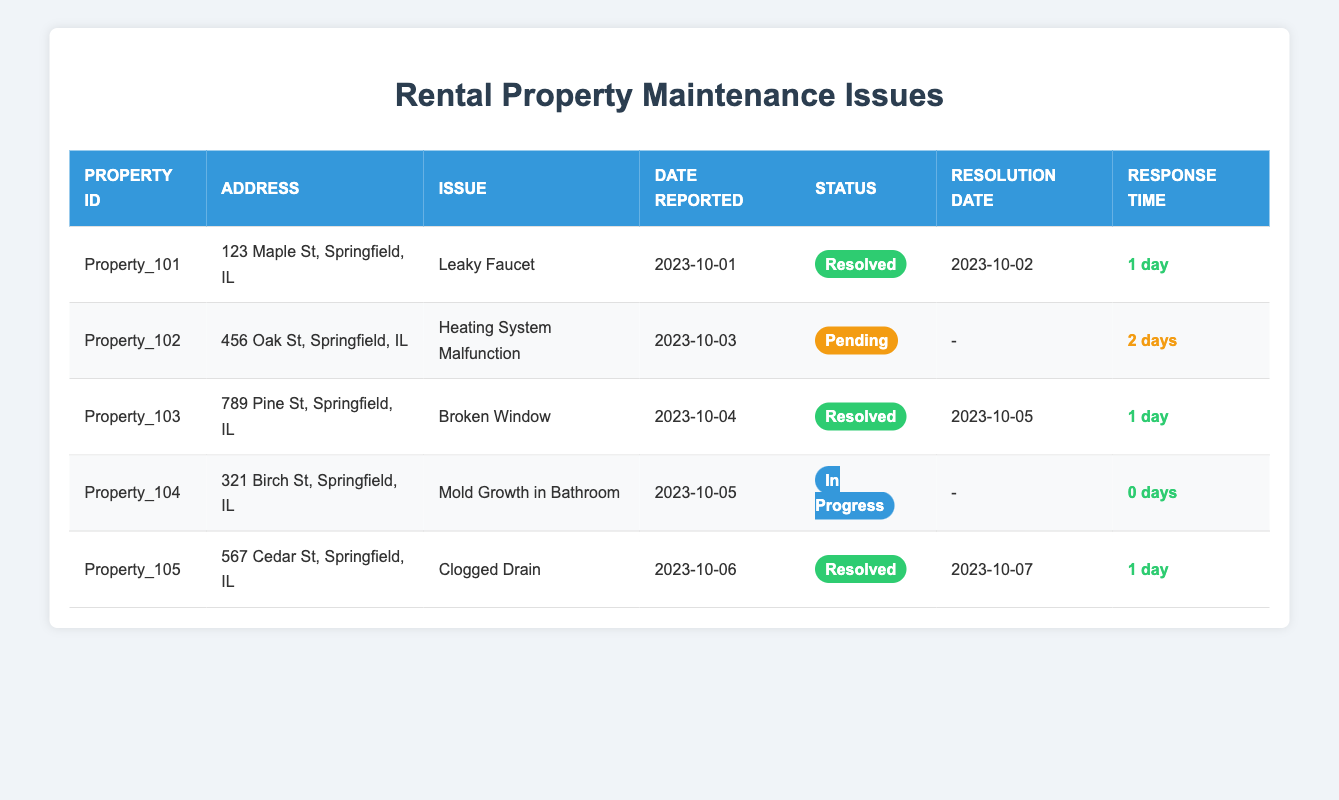What maintenance issue was reported at Property_102? In the data provided, Property_102 has the issue reported as "Heating System Malfunction." This can be directly retrieved from the table where Property_102 is listed.
Answer: Heating System Malfunction How many properties have reported issues that are currently resolved? The table shows that there are three properties with the status "Resolved": Property_101, Property_103, and Property_105. Therefore, the total count is three.
Answer: 3 Which property had the longest response time for a maintenance issue? The longest response time reflected in the table is 2 days for Property_102 with the issue "Heating System Malfunction." This can be determined by comparing the response times listed for all properties.
Answer: Property_102 Is the maintenance issue for Property_104 currently in progress? Yes, the issue for Property_104 is marked as "In Progress," indicating that it has not yet been resolved. This is confirmed by directly reading the status under Property_104 in the table.
Answer: Yes What is the average response time for the resolved issues reported? To calculate the average response time for resolved issues, we consider the response times of Property_101 (1 day), Property_103 (1 day), and Property_105 (1 day), which totals to 1 + 1 + 1 = 3 days. Since there are three resolved issues, the average response time is 3 days / 3 = 1 day.
Answer: 1 day How many maintenance issues are pending as of the last report? Based on the table, there is one maintenance issue pending which is for Property_102. This is confirmed by counting the rows where the status is listed as "Pending."
Answer: 1 Which property has the earliest date reported for a maintenance issue? The earliest reported date in the table is October 1, 2023, for Property_101 with the issue of a "Leaky Faucet." This can be confirmed by reviewing all the entries and comparing their dates.
Answer: Property_101 What was the resolution date for the maintenance issue in Property_105? The resolution date for Property_105 is October 7, 2023. This information can be directly obtained from the corresponding row in the table.
Answer: October 7, 2023 